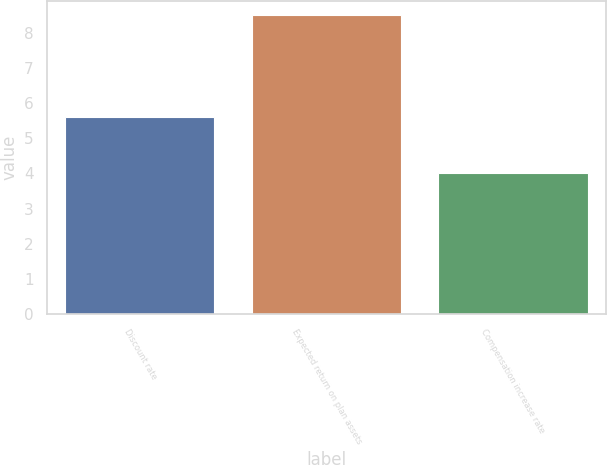Convert chart. <chart><loc_0><loc_0><loc_500><loc_500><bar_chart><fcel>Discount rate<fcel>Expected return on plan assets<fcel>Compensation increase rate<nl><fcel>5.6<fcel>8.5<fcel>4<nl></chart> 